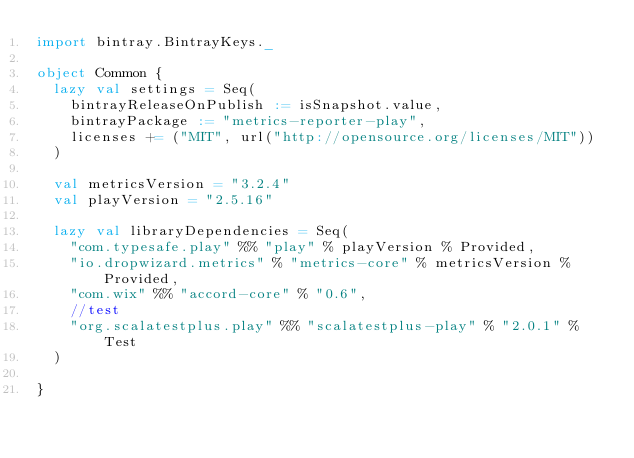Convert code to text. <code><loc_0><loc_0><loc_500><loc_500><_Scala_>import bintray.BintrayKeys._

object Common {
  lazy val settings = Seq(
    bintrayReleaseOnPublish := isSnapshot.value,
    bintrayPackage := "metrics-reporter-play",
    licenses += ("MIT", url("http://opensource.org/licenses/MIT"))
  )

  val metricsVersion = "3.2.4"
  val playVersion = "2.5.16"

  lazy val libraryDependencies = Seq(
    "com.typesafe.play" %% "play" % playVersion % Provided,
    "io.dropwizard.metrics" % "metrics-core" % metricsVersion % Provided,
    "com.wix" %% "accord-core" % "0.6",
    //test
    "org.scalatestplus.play" %% "scalatestplus-play" % "2.0.1" % Test
  )

}
</code> 